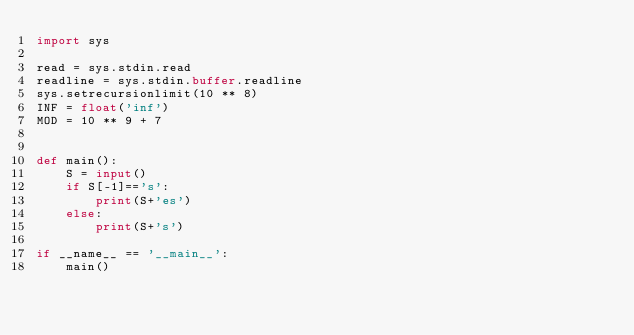Convert code to text. <code><loc_0><loc_0><loc_500><loc_500><_Python_>import sys

read = sys.stdin.read
readline = sys.stdin.buffer.readline
sys.setrecursionlimit(10 ** 8)
INF = float('inf')
MOD = 10 ** 9 + 7


def main():
    S = input()
    if S[-1]=='s':
        print(S+'es')
    else:
        print(S+'s')

if __name__ == '__main__':
    main()
</code> 